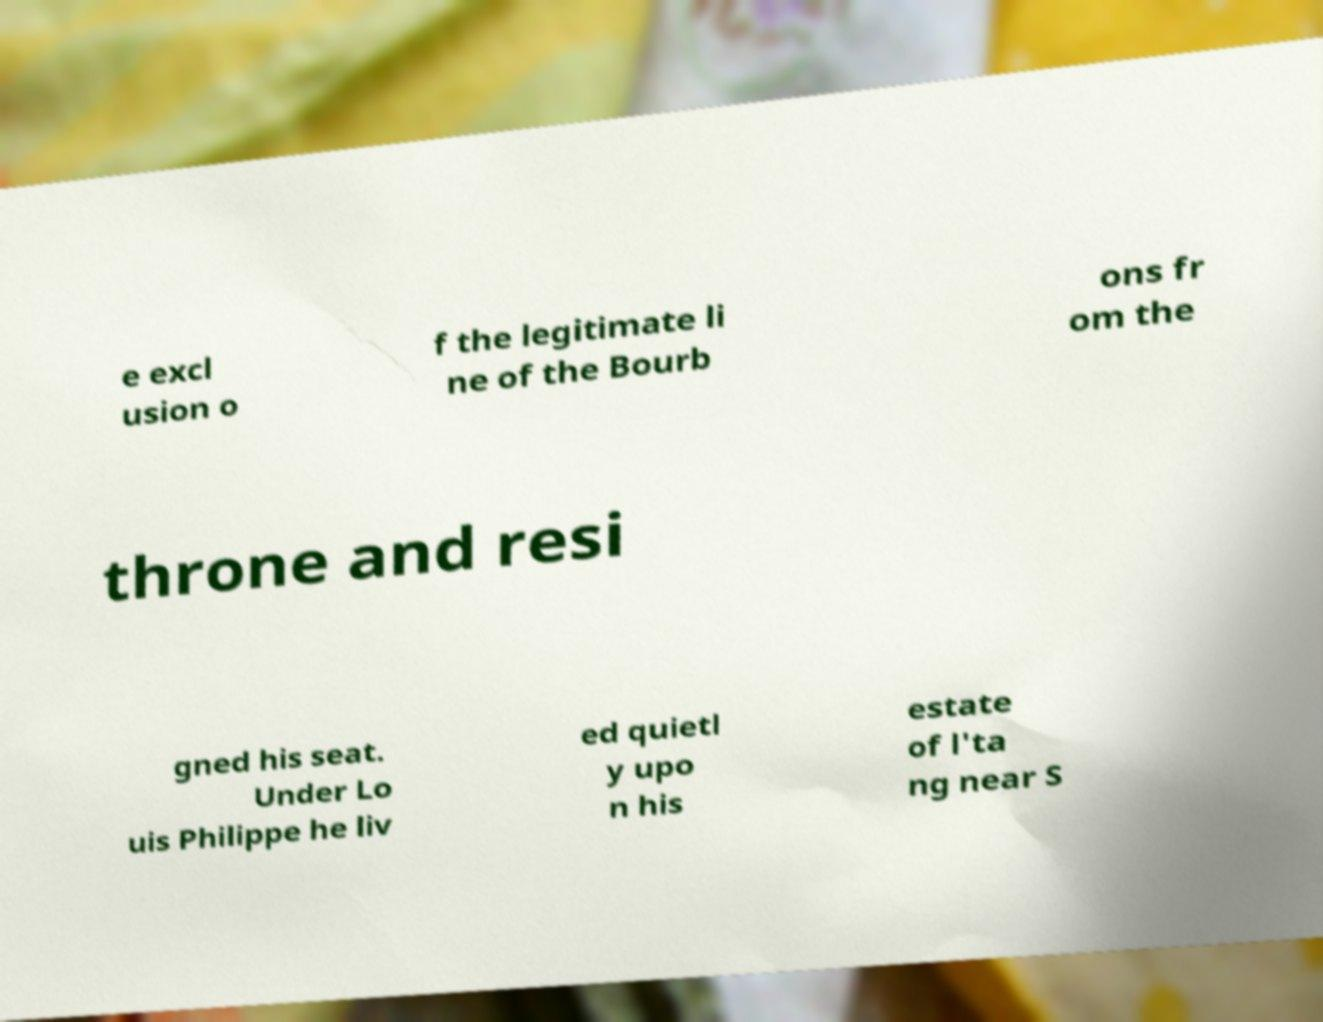Please read and relay the text visible in this image. What does it say? e excl usion o f the legitimate li ne of the Bourb ons fr om the throne and resi gned his seat. Under Lo uis Philippe he liv ed quietl y upo n his estate of l'ta ng near S 